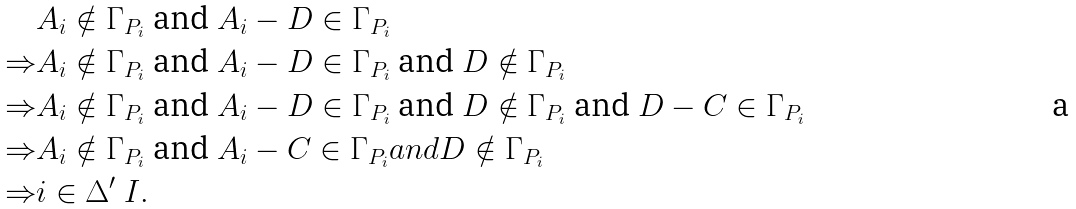Convert formula to latex. <formula><loc_0><loc_0><loc_500><loc_500>& A _ { i } \notin \Gamma _ { P _ { i } } \text { and } A _ { i } - D \in \Gamma _ { P _ { i } } \\ \Rightarrow & A _ { i } \notin \Gamma _ { P _ { i } } \text { and } A _ { i } - D \in \Gamma _ { P _ { i } } \text { and } D \notin \Gamma _ { P _ { i } } \\ \Rightarrow & A _ { i } \notin \Gamma _ { P _ { i } } \text { and } A _ { i } - D \in \Gamma _ { P _ { i } } \text { and } D \notin \Gamma _ { P _ { i } } \text { and } D - C \in \Gamma _ { P _ { i } } \\ \Rightarrow & A _ { i } \notin \Gamma _ { P _ { i } } \text { and } A _ { i } - C \in \Gamma _ { P _ { i } } a n d D \notin \Gamma _ { P _ { i } } \\ \Rightarrow & i \in \Delta ^ { \prime } \ I .</formula> 